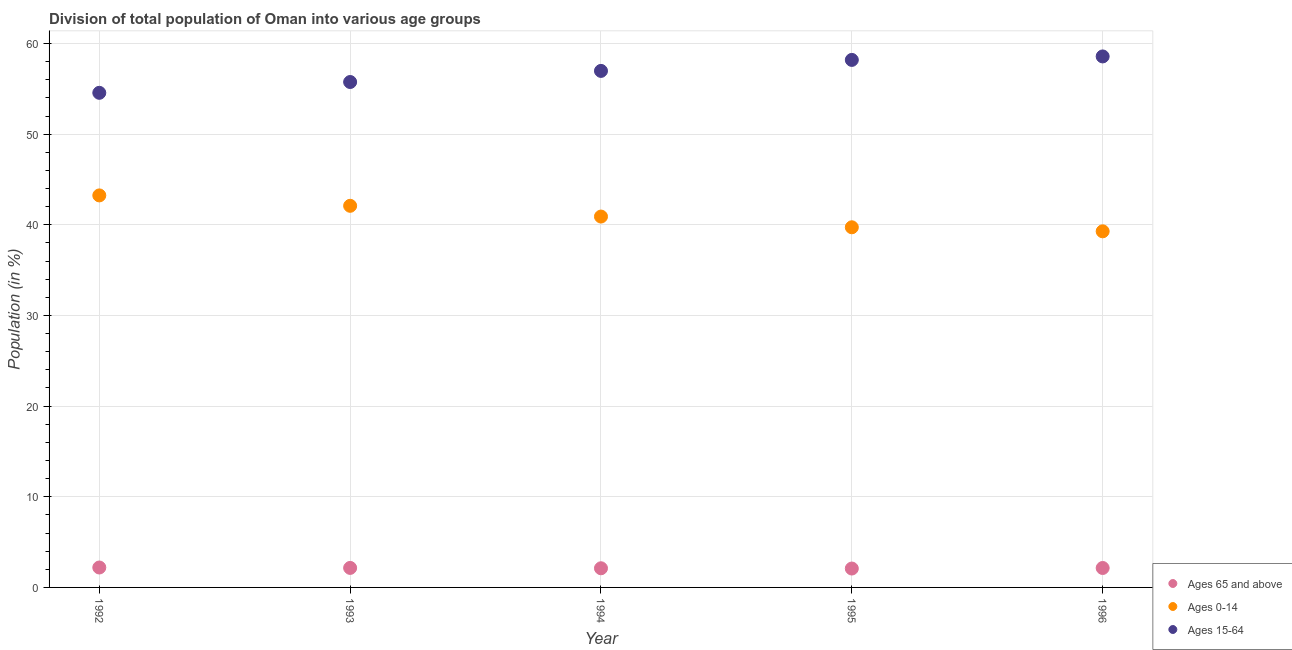How many different coloured dotlines are there?
Offer a very short reply. 3. Is the number of dotlines equal to the number of legend labels?
Give a very brief answer. Yes. What is the percentage of population within the age-group of 65 and above in 1995?
Your answer should be compact. 2.08. Across all years, what is the maximum percentage of population within the age-group 0-14?
Ensure brevity in your answer.  43.24. Across all years, what is the minimum percentage of population within the age-group 15-64?
Make the answer very short. 54.56. In which year was the percentage of population within the age-group 0-14 maximum?
Your answer should be very brief. 1992. What is the total percentage of population within the age-group 15-64 in the graph?
Make the answer very short. 284.05. What is the difference between the percentage of population within the age-group 0-14 in 1992 and that in 1993?
Keep it short and to the point. 1.15. What is the difference between the percentage of population within the age-group 0-14 in 1996 and the percentage of population within the age-group of 65 and above in 1992?
Your response must be concise. 37.08. What is the average percentage of population within the age-group 0-14 per year?
Offer a terse response. 41.05. In the year 1993, what is the difference between the percentage of population within the age-group 0-14 and percentage of population within the age-group 15-64?
Ensure brevity in your answer.  -13.66. In how many years, is the percentage of population within the age-group 0-14 greater than 44 %?
Provide a short and direct response. 0. What is the ratio of the percentage of population within the age-group 15-64 in 1994 to that in 1995?
Ensure brevity in your answer.  0.98. Is the percentage of population within the age-group 0-14 in 1992 less than that in 1993?
Your response must be concise. No. What is the difference between the highest and the second highest percentage of population within the age-group 0-14?
Your response must be concise. 1.15. What is the difference between the highest and the lowest percentage of population within the age-group 15-64?
Your response must be concise. 4.01. In how many years, is the percentage of population within the age-group of 65 and above greater than the average percentage of population within the age-group of 65 and above taken over all years?
Provide a succinct answer. 3. Is it the case that in every year, the sum of the percentage of population within the age-group of 65 and above and percentage of population within the age-group 0-14 is greater than the percentage of population within the age-group 15-64?
Ensure brevity in your answer.  No. Does the graph contain any zero values?
Ensure brevity in your answer.  No. How are the legend labels stacked?
Ensure brevity in your answer.  Vertical. What is the title of the graph?
Offer a terse response. Division of total population of Oman into various age groups
. What is the Population (in %) of Ages 65 and above in 1992?
Offer a terse response. 2.2. What is the Population (in %) in Ages 0-14 in 1992?
Keep it short and to the point. 43.24. What is the Population (in %) in Ages 15-64 in 1992?
Your response must be concise. 54.56. What is the Population (in %) in Ages 65 and above in 1993?
Offer a terse response. 2.15. What is the Population (in %) in Ages 0-14 in 1993?
Provide a succinct answer. 42.1. What is the Population (in %) of Ages 15-64 in 1993?
Your answer should be very brief. 55.75. What is the Population (in %) of Ages 65 and above in 1994?
Keep it short and to the point. 2.11. What is the Population (in %) of Ages 0-14 in 1994?
Make the answer very short. 40.91. What is the Population (in %) of Ages 15-64 in 1994?
Your answer should be very brief. 56.98. What is the Population (in %) in Ages 65 and above in 1995?
Offer a terse response. 2.08. What is the Population (in %) of Ages 0-14 in 1995?
Offer a terse response. 39.73. What is the Population (in %) of Ages 15-64 in 1995?
Keep it short and to the point. 58.19. What is the Population (in %) of Ages 65 and above in 1996?
Offer a terse response. 2.14. What is the Population (in %) in Ages 0-14 in 1996?
Keep it short and to the point. 39.28. What is the Population (in %) in Ages 15-64 in 1996?
Make the answer very short. 58.57. Across all years, what is the maximum Population (in %) of Ages 65 and above?
Your response must be concise. 2.2. Across all years, what is the maximum Population (in %) of Ages 0-14?
Keep it short and to the point. 43.24. Across all years, what is the maximum Population (in %) of Ages 15-64?
Your answer should be compact. 58.57. Across all years, what is the minimum Population (in %) in Ages 65 and above?
Ensure brevity in your answer.  2.08. Across all years, what is the minimum Population (in %) of Ages 0-14?
Ensure brevity in your answer.  39.28. Across all years, what is the minimum Population (in %) of Ages 15-64?
Offer a terse response. 54.56. What is the total Population (in %) of Ages 65 and above in the graph?
Provide a succinct answer. 10.69. What is the total Population (in %) in Ages 0-14 in the graph?
Your response must be concise. 205.26. What is the total Population (in %) of Ages 15-64 in the graph?
Keep it short and to the point. 284.05. What is the difference between the Population (in %) of Ages 65 and above in 1992 and that in 1993?
Ensure brevity in your answer.  0.05. What is the difference between the Population (in %) of Ages 0-14 in 1992 and that in 1993?
Your response must be concise. 1.15. What is the difference between the Population (in %) in Ages 15-64 in 1992 and that in 1993?
Provide a short and direct response. -1.19. What is the difference between the Population (in %) in Ages 65 and above in 1992 and that in 1994?
Offer a terse response. 0.08. What is the difference between the Population (in %) of Ages 0-14 in 1992 and that in 1994?
Keep it short and to the point. 2.33. What is the difference between the Population (in %) of Ages 15-64 in 1992 and that in 1994?
Provide a short and direct response. -2.42. What is the difference between the Population (in %) of Ages 65 and above in 1992 and that in 1995?
Offer a very short reply. 0.11. What is the difference between the Population (in %) in Ages 0-14 in 1992 and that in 1995?
Offer a very short reply. 3.52. What is the difference between the Population (in %) in Ages 15-64 in 1992 and that in 1995?
Make the answer very short. -3.63. What is the difference between the Population (in %) in Ages 65 and above in 1992 and that in 1996?
Your response must be concise. 0.05. What is the difference between the Population (in %) in Ages 0-14 in 1992 and that in 1996?
Provide a succinct answer. 3.96. What is the difference between the Population (in %) in Ages 15-64 in 1992 and that in 1996?
Keep it short and to the point. -4.01. What is the difference between the Population (in %) in Ages 65 and above in 1993 and that in 1994?
Give a very brief answer. 0.04. What is the difference between the Population (in %) in Ages 0-14 in 1993 and that in 1994?
Your answer should be very brief. 1.19. What is the difference between the Population (in %) in Ages 15-64 in 1993 and that in 1994?
Your response must be concise. -1.22. What is the difference between the Population (in %) in Ages 65 and above in 1993 and that in 1995?
Offer a terse response. 0.07. What is the difference between the Population (in %) in Ages 0-14 in 1993 and that in 1995?
Give a very brief answer. 2.37. What is the difference between the Population (in %) of Ages 15-64 in 1993 and that in 1995?
Your response must be concise. -2.44. What is the difference between the Population (in %) in Ages 65 and above in 1993 and that in 1996?
Make the answer very short. 0.01. What is the difference between the Population (in %) of Ages 0-14 in 1993 and that in 1996?
Provide a succinct answer. 2.81. What is the difference between the Population (in %) of Ages 15-64 in 1993 and that in 1996?
Make the answer very short. -2.82. What is the difference between the Population (in %) in Ages 65 and above in 1994 and that in 1995?
Provide a short and direct response. 0.03. What is the difference between the Population (in %) of Ages 0-14 in 1994 and that in 1995?
Your answer should be compact. 1.18. What is the difference between the Population (in %) in Ages 15-64 in 1994 and that in 1995?
Keep it short and to the point. -1.21. What is the difference between the Population (in %) in Ages 65 and above in 1994 and that in 1996?
Your answer should be very brief. -0.03. What is the difference between the Population (in %) of Ages 0-14 in 1994 and that in 1996?
Offer a terse response. 1.63. What is the difference between the Population (in %) of Ages 15-64 in 1994 and that in 1996?
Offer a very short reply. -1.6. What is the difference between the Population (in %) in Ages 65 and above in 1995 and that in 1996?
Make the answer very short. -0.06. What is the difference between the Population (in %) in Ages 0-14 in 1995 and that in 1996?
Ensure brevity in your answer.  0.44. What is the difference between the Population (in %) of Ages 15-64 in 1995 and that in 1996?
Ensure brevity in your answer.  -0.38. What is the difference between the Population (in %) of Ages 65 and above in 1992 and the Population (in %) of Ages 0-14 in 1993?
Offer a terse response. -39.9. What is the difference between the Population (in %) of Ages 65 and above in 1992 and the Population (in %) of Ages 15-64 in 1993?
Ensure brevity in your answer.  -53.55. What is the difference between the Population (in %) in Ages 0-14 in 1992 and the Population (in %) in Ages 15-64 in 1993?
Give a very brief answer. -12.51. What is the difference between the Population (in %) of Ages 65 and above in 1992 and the Population (in %) of Ages 0-14 in 1994?
Your answer should be very brief. -38.71. What is the difference between the Population (in %) of Ages 65 and above in 1992 and the Population (in %) of Ages 15-64 in 1994?
Make the answer very short. -54.78. What is the difference between the Population (in %) of Ages 0-14 in 1992 and the Population (in %) of Ages 15-64 in 1994?
Provide a succinct answer. -13.73. What is the difference between the Population (in %) of Ages 65 and above in 1992 and the Population (in %) of Ages 0-14 in 1995?
Your answer should be compact. -37.53. What is the difference between the Population (in %) in Ages 65 and above in 1992 and the Population (in %) in Ages 15-64 in 1995?
Your answer should be compact. -55.99. What is the difference between the Population (in %) in Ages 0-14 in 1992 and the Population (in %) in Ages 15-64 in 1995?
Offer a terse response. -14.95. What is the difference between the Population (in %) of Ages 65 and above in 1992 and the Population (in %) of Ages 0-14 in 1996?
Your answer should be very brief. -37.08. What is the difference between the Population (in %) in Ages 65 and above in 1992 and the Population (in %) in Ages 15-64 in 1996?
Provide a short and direct response. -56.38. What is the difference between the Population (in %) of Ages 0-14 in 1992 and the Population (in %) of Ages 15-64 in 1996?
Make the answer very short. -15.33. What is the difference between the Population (in %) in Ages 65 and above in 1993 and the Population (in %) in Ages 0-14 in 1994?
Your answer should be very brief. -38.76. What is the difference between the Population (in %) of Ages 65 and above in 1993 and the Population (in %) of Ages 15-64 in 1994?
Offer a very short reply. -54.82. What is the difference between the Population (in %) in Ages 0-14 in 1993 and the Population (in %) in Ages 15-64 in 1994?
Make the answer very short. -14.88. What is the difference between the Population (in %) of Ages 65 and above in 1993 and the Population (in %) of Ages 0-14 in 1995?
Your answer should be compact. -37.57. What is the difference between the Population (in %) in Ages 65 and above in 1993 and the Population (in %) in Ages 15-64 in 1995?
Ensure brevity in your answer.  -56.04. What is the difference between the Population (in %) of Ages 0-14 in 1993 and the Population (in %) of Ages 15-64 in 1995?
Offer a very short reply. -16.09. What is the difference between the Population (in %) in Ages 65 and above in 1993 and the Population (in %) in Ages 0-14 in 1996?
Provide a succinct answer. -37.13. What is the difference between the Population (in %) of Ages 65 and above in 1993 and the Population (in %) of Ages 15-64 in 1996?
Your answer should be very brief. -56.42. What is the difference between the Population (in %) in Ages 0-14 in 1993 and the Population (in %) in Ages 15-64 in 1996?
Provide a succinct answer. -16.48. What is the difference between the Population (in %) in Ages 65 and above in 1994 and the Population (in %) in Ages 0-14 in 1995?
Offer a terse response. -37.61. What is the difference between the Population (in %) in Ages 65 and above in 1994 and the Population (in %) in Ages 15-64 in 1995?
Provide a succinct answer. -56.08. What is the difference between the Population (in %) of Ages 0-14 in 1994 and the Population (in %) of Ages 15-64 in 1995?
Offer a terse response. -17.28. What is the difference between the Population (in %) of Ages 65 and above in 1994 and the Population (in %) of Ages 0-14 in 1996?
Provide a succinct answer. -37.17. What is the difference between the Population (in %) in Ages 65 and above in 1994 and the Population (in %) in Ages 15-64 in 1996?
Provide a short and direct response. -56.46. What is the difference between the Population (in %) in Ages 0-14 in 1994 and the Population (in %) in Ages 15-64 in 1996?
Ensure brevity in your answer.  -17.66. What is the difference between the Population (in %) in Ages 65 and above in 1995 and the Population (in %) in Ages 0-14 in 1996?
Provide a succinct answer. -37.2. What is the difference between the Population (in %) of Ages 65 and above in 1995 and the Population (in %) of Ages 15-64 in 1996?
Offer a very short reply. -56.49. What is the difference between the Population (in %) in Ages 0-14 in 1995 and the Population (in %) in Ages 15-64 in 1996?
Provide a short and direct response. -18.85. What is the average Population (in %) of Ages 65 and above per year?
Give a very brief answer. 2.14. What is the average Population (in %) in Ages 0-14 per year?
Your response must be concise. 41.05. What is the average Population (in %) in Ages 15-64 per year?
Your answer should be compact. 56.81. In the year 1992, what is the difference between the Population (in %) of Ages 65 and above and Population (in %) of Ages 0-14?
Provide a short and direct response. -41.05. In the year 1992, what is the difference between the Population (in %) of Ages 65 and above and Population (in %) of Ages 15-64?
Offer a terse response. -52.36. In the year 1992, what is the difference between the Population (in %) of Ages 0-14 and Population (in %) of Ages 15-64?
Your response must be concise. -11.32. In the year 1993, what is the difference between the Population (in %) of Ages 65 and above and Population (in %) of Ages 0-14?
Keep it short and to the point. -39.94. In the year 1993, what is the difference between the Population (in %) in Ages 65 and above and Population (in %) in Ages 15-64?
Provide a short and direct response. -53.6. In the year 1993, what is the difference between the Population (in %) in Ages 0-14 and Population (in %) in Ages 15-64?
Provide a succinct answer. -13.66. In the year 1994, what is the difference between the Population (in %) of Ages 65 and above and Population (in %) of Ages 0-14?
Provide a succinct answer. -38.8. In the year 1994, what is the difference between the Population (in %) in Ages 65 and above and Population (in %) in Ages 15-64?
Your answer should be very brief. -54.86. In the year 1994, what is the difference between the Population (in %) of Ages 0-14 and Population (in %) of Ages 15-64?
Your response must be concise. -16.07. In the year 1995, what is the difference between the Population (in %) in Ages 65 and above and Population (in %) in Ages 0-14?
Ensure brevity in your answer.  -37.64. In the year 1995, what is the difference between the Population (in %) in Ages 65 and above and Population (in %) in Ages 15-64?
Your answer should be very brief. -56.11. In the year 1995, what is the difference between the Population (in %) in Ages 0-14 and Population (in %) in Ages 15-64?
Ensure brevity in your answer.  -18.46. In the year 1996, what is the difference between the Population (in %) in Ages 65 and above and Population (in %) in Ages 0-14?
Your response must be concise. -37.14. In the year 1996, what is the difference between the Population (in %) in Ages 65 and above and Population (in %) in Ages 15-64?
Offer a very short reply. -56.43. In the year 1996, what is the difference between the Population (in %) in Ages 0-14 and Population (in %) in Ages 15-64?
Provide a short and direct response. -19.29. What is the ratio of the Population (in %) of Ages 65 and above in 1992 to that in 1993?
Keep it short and to the point. 1.02. What is the ratio of the Population (in %) of Ages 0-14 in 1992 to that in 1993?
Ensure brevity in your answer.  1.03. What is the ratio of the Population (in %) of Ages 15-64 in 1992 to that in 1993?
Provide a succinct answer. 0.98. What is the ratio of the Population (in %) in Ages 0-14 in 1992 to that in 1994?
Give a very brief answer. 1.06. What is the ratio of the Population (in %) of Ages 15-64 in 1992 to that in 1994?
Give a very brief answer. 0.96. What is the ratio of the Population (in %) of Ages 65 and above in 1992 to that in 1995?
Your answer should be very brief. 1.05. What is the ratio of the Population (in %) in Ages 0-14 in 1992 to that in 1995?
Your answer should be compact. 1.09. What is the ratio of the Population (in %) of Ages 15-64 in 1992 to that in 1995?
Give a very brief answer. 0.94. What is the ratio of the Population (in %) in Ages 65 and above in 1992 to that in 1996?
Provide a succinct answer. 1.02. What is the ratio of the Population (in %) of Ages 0-14 in 1992 to that in 1996?
Offer a very short reply. 1.1. What is the ratio of the Population (in %) of Ages 15-64 in 1992 to that in 1996?
Keep it short and to the point. 0.93. What is the ratio of the Population (in %) of Ages 65 and above in 1993 to that in 1994?
Offer a terse response. 1.02. What is the ratio of the Population (in %) of Ages 15-64 in 1993 to that in 1994?
Provide a short and direct response. 0.98. What is the ratio of the Population (in %) in Ages 65 and above in 1993 to that in 1995?
Provide a short and direct response. 1.03. What is the ratio of the Population (in %) in Ages 0-14 in 1993 to that in 1995?
Offer a terse response. 1.06. What is the ratio of the Population (in %) of Ages 15-64 in 1993 to that in 1995?
Make the answer very short. 0.96. What is the ratio of the Population (in %) in Ages 0-14 in 1993 to that in 1996?
Your response must be concise. 1.07. What is the ratio of the Population (in %) in Ages 15-64 in 1993 to that in 1996?
Provide a short and direct response. 0.95. What is the ratio of the Population (in %) of Ages 65 and above in 1994 to that in 1995?
Keep it short and to the point. 1.01. What is the ratio of the Population (in %) of Ages 0-14 in 1994 to that in 1995?
Your response must be concise. 1.03. What is the ratio of the Population (in %) in Ages 15-64 in 1994 to that in 1995?
Provide a short and direct response. 0.98. What is the ratio of the Population (in %) of Ages 65 and above in 1994 to that in 1996?
Offer a very short reply. 0.99. What is the ratio of the Population (in %) of Ages 0-14 in 1994 to that in 1996?
Offer a very short reply. 1.04. What is the ratio of the Population (in %) of Ages 15-64 in 1994 to that in 1996?
Provide a succinct answer. 0.97. What is the ratio of the Population (in %) of Ages 65 and above in 1995 to that in 1996?
Offer a terse response. 0.97. What is the ratio of the Population (in %) in Ages 0-14 in 1995 to that in 1996?
Give a very brief answer. 1.01. What is the difference between the highest and the second highest Population (in %) in Ages 65 and above?
Ensure brevity in your answer.  0.05. What is the difference between the highest and the second highest Population (in %) in Ages 0-14?
Provide a short and direct response. 1.15. What is the difference between the highest and the second highest Population (in %) of Ages 15-64?
Your answer should be compact. 0.38. What is the difference between the highest and the lowest Population (in %) in Ages 65 and above?
Make the answer very short. 0.11. What is the difference between the highest and the lowest Population (in %) in Ages 0-14?
Your answer should be very brief. 3.96. What is the difference between the highest and the lowest Population (in %) of Ages 15-64?
Offer a terse response. 4.01. 